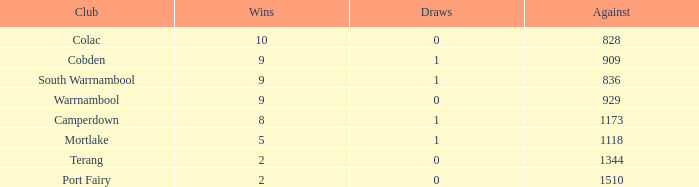What is the sum of against values for clubs that have over 2 victories, 5 defeats, and no ties? 0.0. 